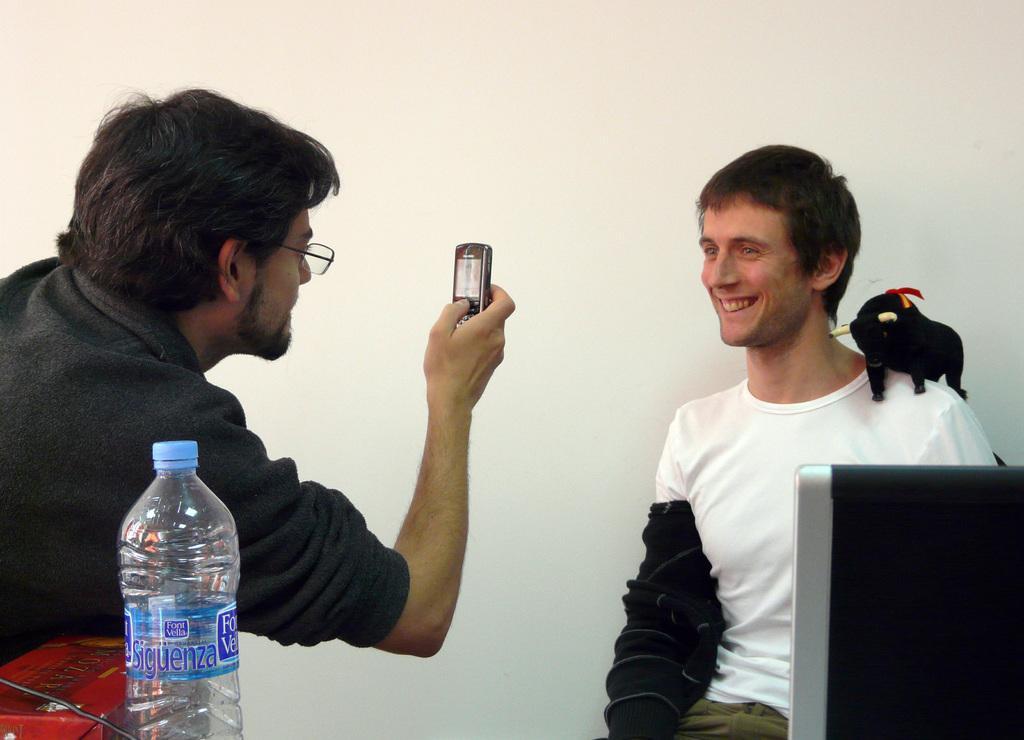How would you summarize this image in a sentence or two? On the right there is a man he is smiling ,he wear white t shirt. On the left there is a man he wear black t shirt, he holds a mobile. 